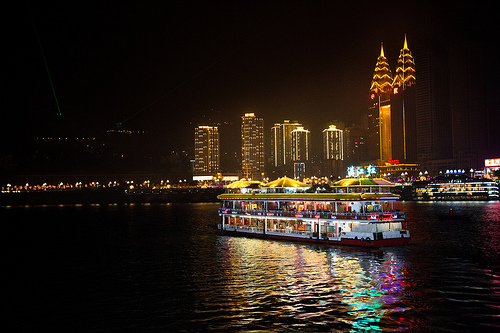Do you see yellow cans or umbrellas? Yes, there are yellow umbrellas visible in the image. 